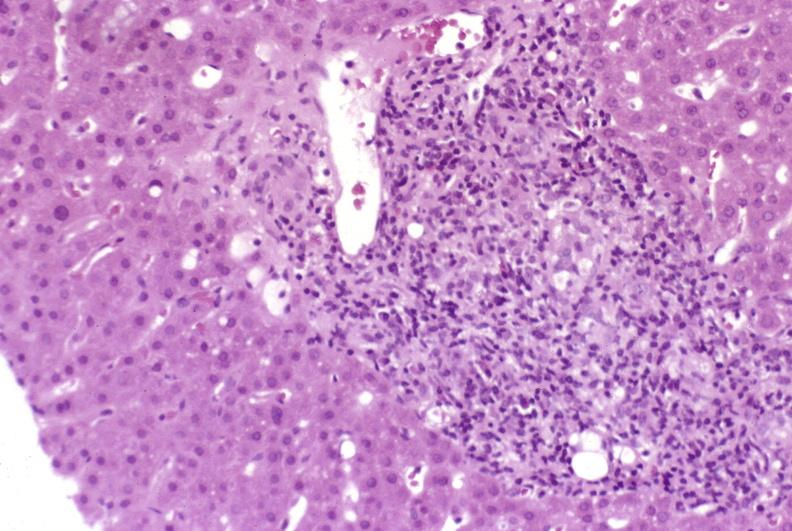what is present?
Answer the question using a single word or phrase. Liver 